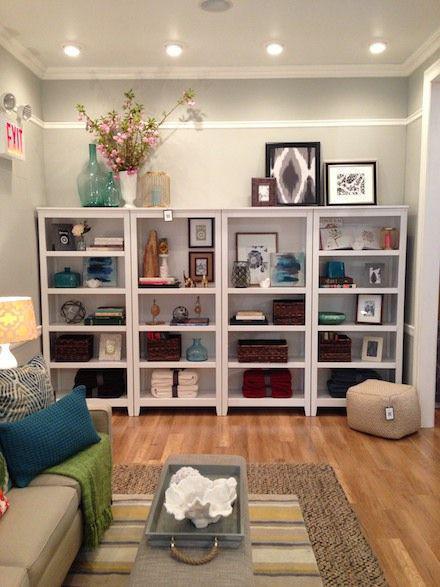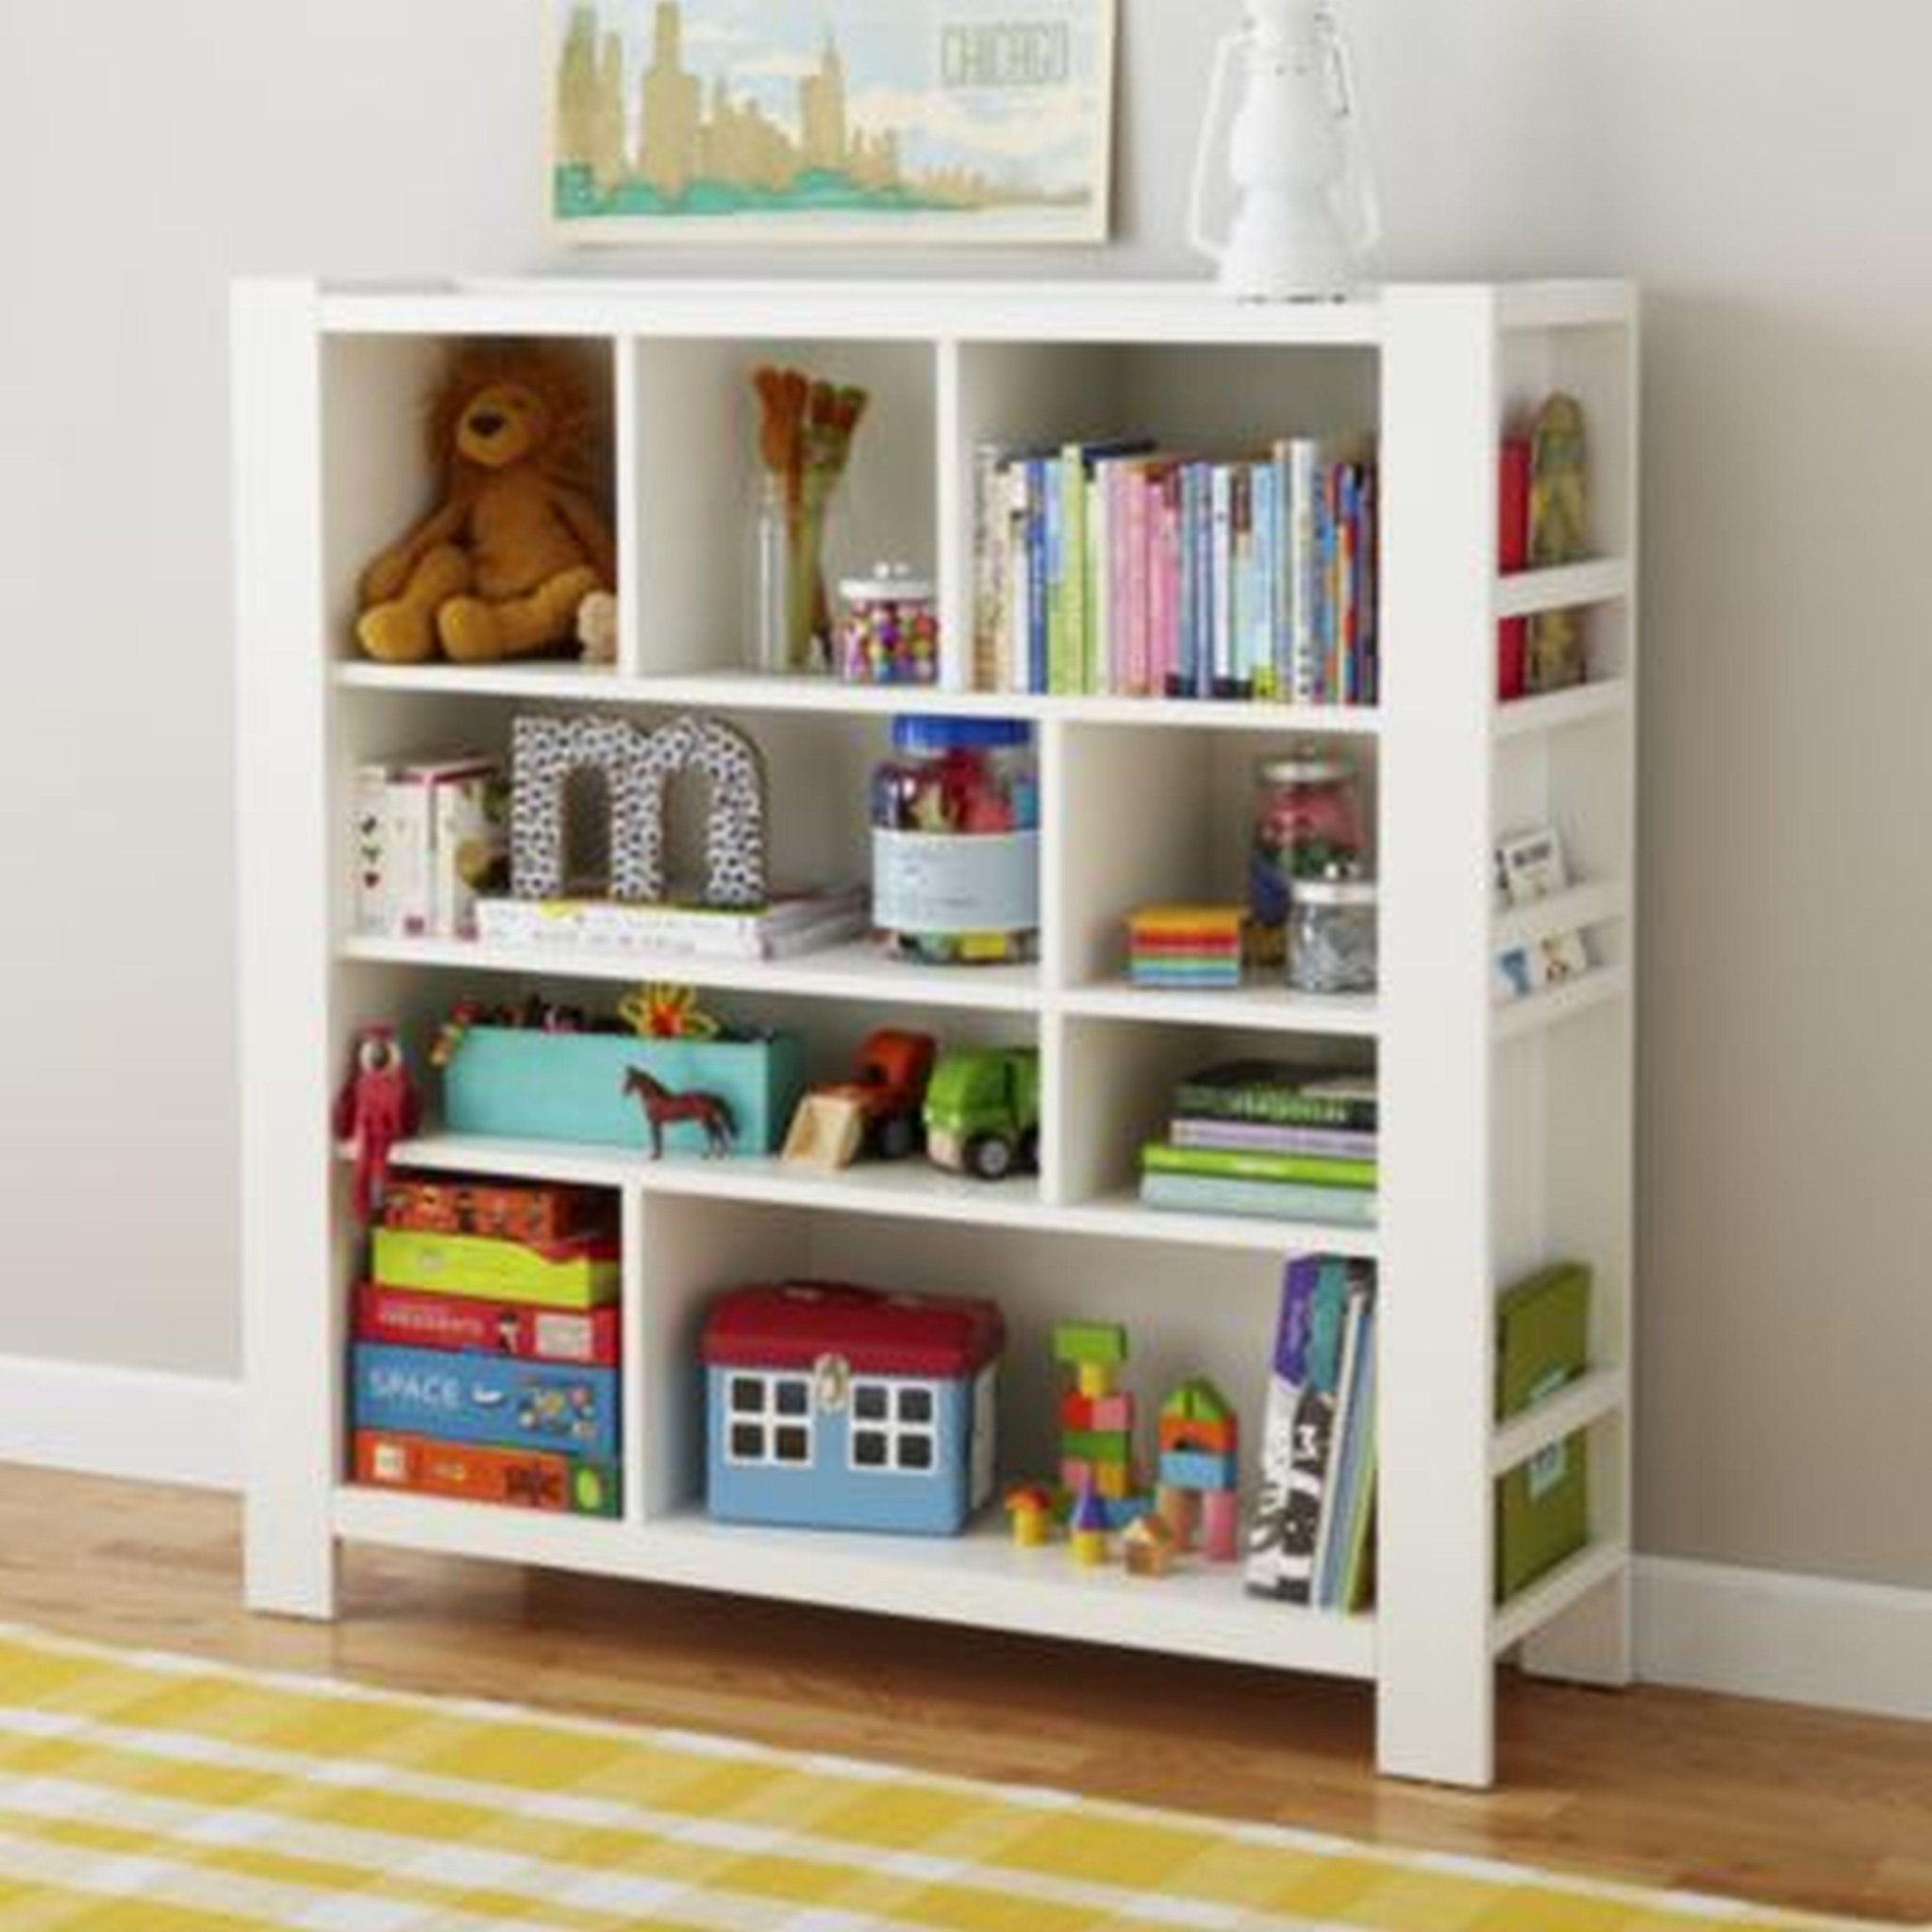The first image is the image on the left, the second image is the image on the right. Analyze the images presented: Is the assertion "At least three pillows are in a window seat in one of the images." valid? Answer yes or no. No. The first image is the image on the left, the second image is the image on the right. For the images displayed, is the sentence "There is an office chair in front of a desk that has four drawers." factually correct? Answer yes or no. No. 